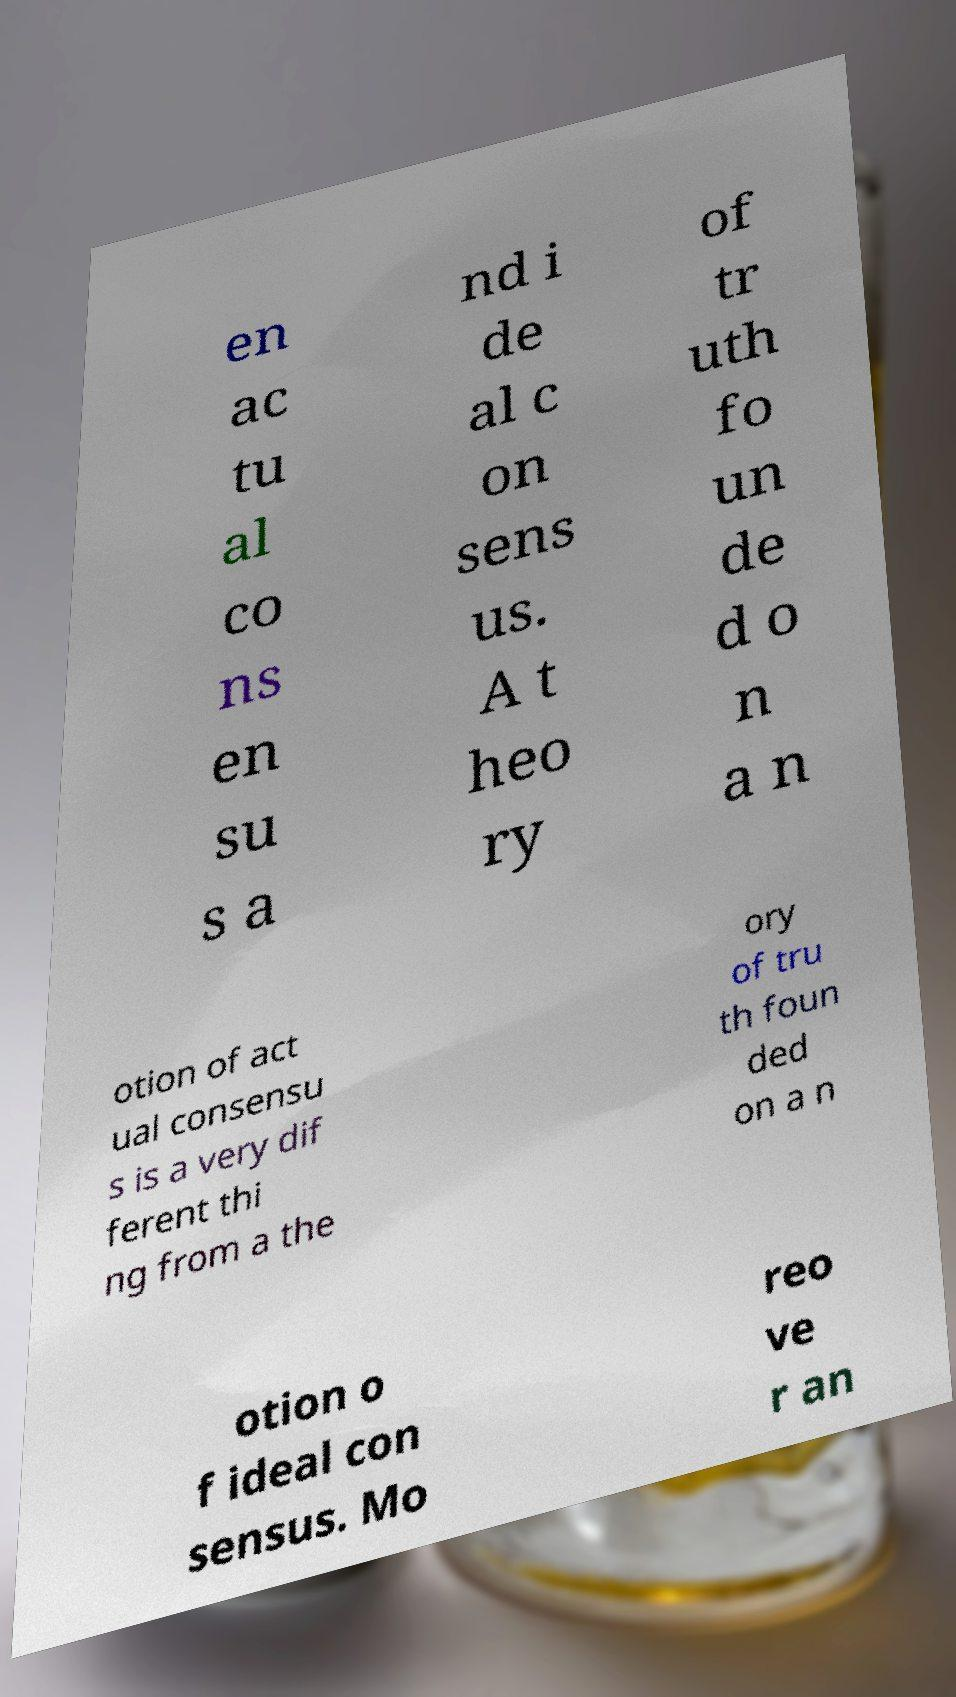Could you extract and type out the text from this image? en ac tu al co ns en su s a nd i de al c on sens us. A t heo ry of tr uth fo un de d o n a n otion of act ual consensu s is a very dif ferent thi ng from a the ory of tru th foun ded on a n otion o f ideal con sensus. Mo reo ve r an 